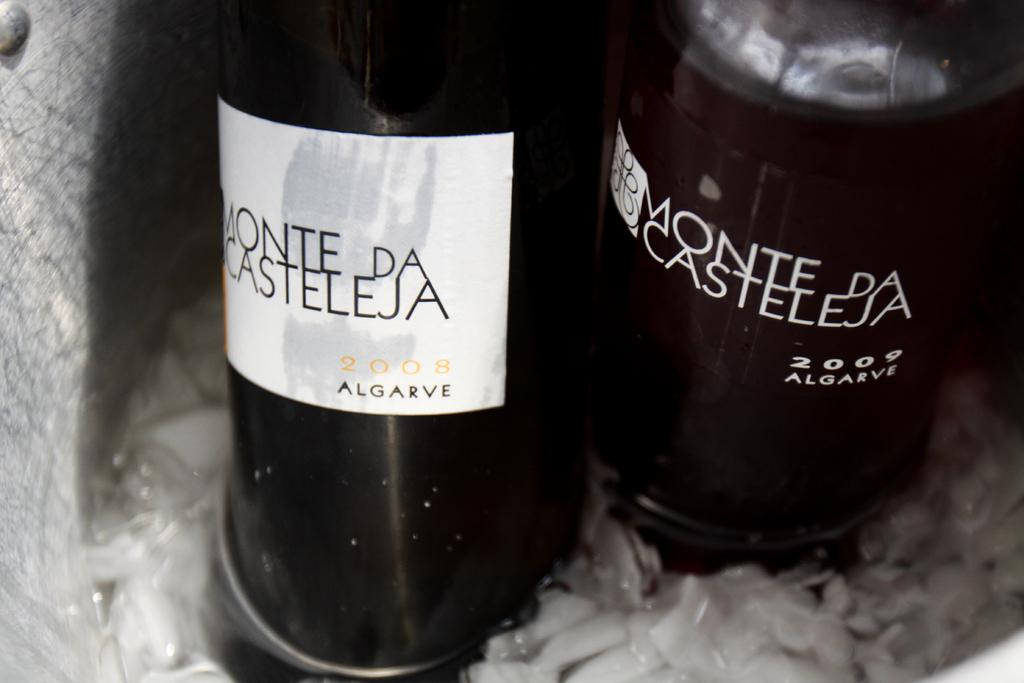<image>
Provide a brief description of the given image. A bottle of wine called Monte de Casteleja 